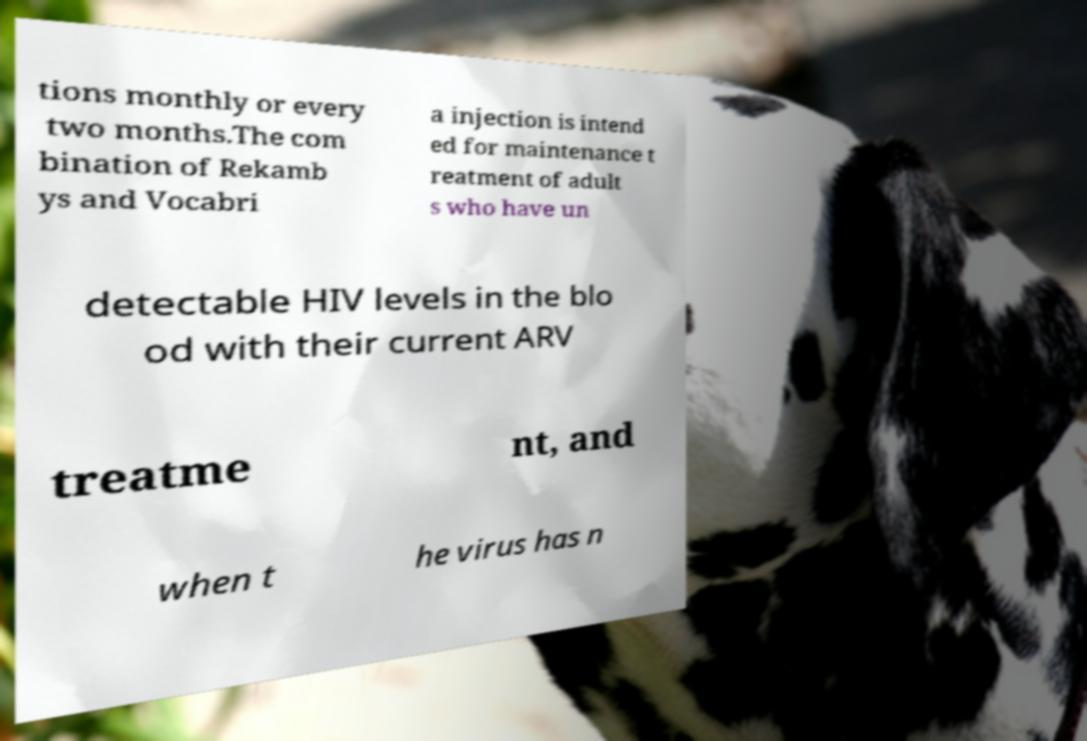For documentation purposes, I need the text within this image transcribed. Could you provide that? tions monthly or every two months.The com bination of Rekamb ys and Vocabri a injection is intend ed for maintenance t reatment of adult s who have un detectable HIV levels in the blo od with their current ARV treatme nt, and when t he virus has n 